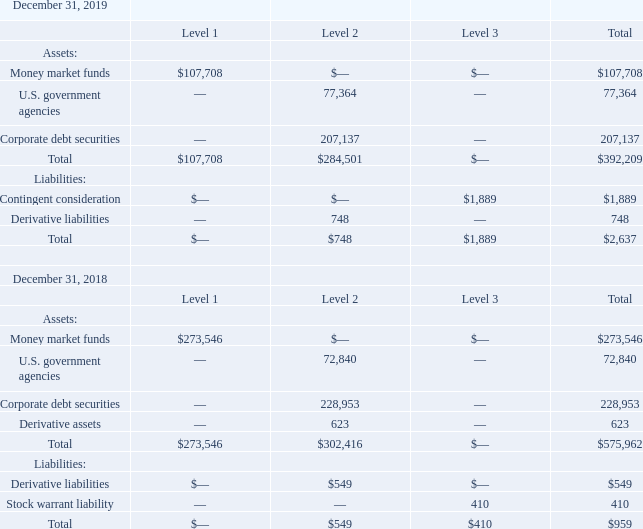Fair Value Measurement of Financial Assets and Liabilities
The carrying values of the Company’s accounts receivable and accounts payable, approximated their fair values due to the short period of time to maturity or repayment.
The following tables set forth the Company’s financial instruments that were measured at fair value on a recurring basis by level within the fair value hierarchy (in thousands):
The fair value of the Company’s Level 1 financial instruments is based on quoted market prices in active markets for identical instruments. The fair value of the Company’s Level 2 financial instruments is based on observable inputs other than quoted prices in active markets for identical assets and liabilities, quoted prices for identical or similar assets or liabilities in inactive markets, or other inputs that are observable or can be corroborated by observable market data.
In addition, Level 2 assets and liabilities include derivative financial instruments associated with hedging activity, which are further discussed in Note 4. Derivative financial instruments are initially measured at fair value on the contract date and are subsequently remeasured to fair value at each reporting date using inputs such as spot rates, forward rates, and discount rates. There is not an active market for each hedge contract, but the inputs used to calculate the value of the instruments are tied to active markets.
What is the fair value of the Company's Level 1 financial instruments based on? Quoted market prices in active markets for identical instruments. What inputs are used to remeasure derivative financial instruments at each reporting date? Spot rates, forward rates, and discount rates. What is the total liabilities for all levels as of December 31, 2018?
Answer scale should be: thousand. $959. What is the difference in the total assets between Level 1 and Level 2 as of December 31, 2019?
Answer scale should be: thousand. $284,501- $107,708
Answer: 176793. What is the percentage constitution of money market funds among the total assets as of December 31, 2019?
Answer scale should be: percent. 107,708/392,209
Answer: 27.46. What is the average total liabilities for 2018 and 2019?
Answer scale should be: thousand. (2,637+959)/2
Answer: 1798. 